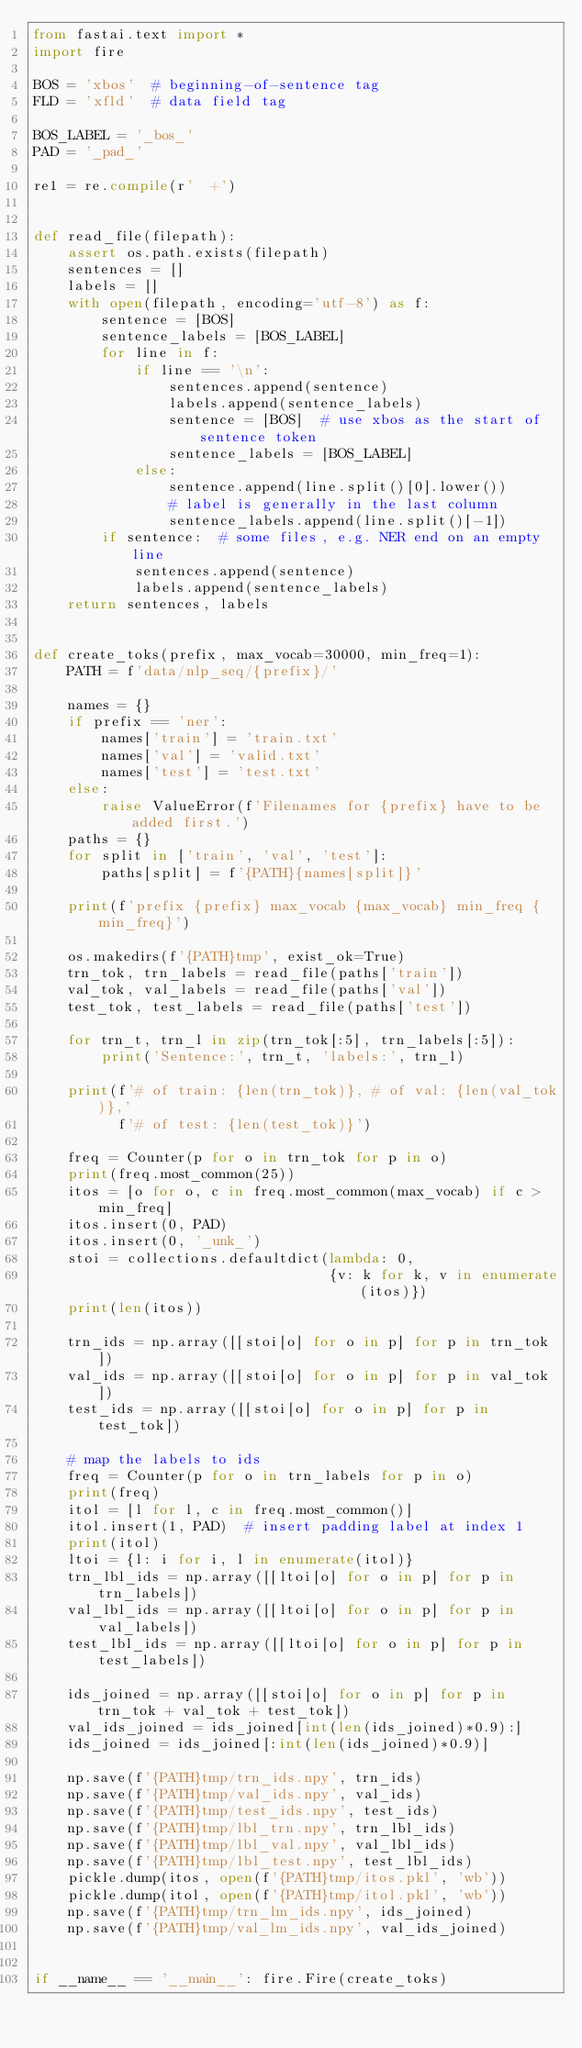<code> <loc_0><loc_0><loc_500><loc_500><_Python_>from fastai.text import *
import fire

BOS = 'xbos'  # beginning-of-sentence tag
FLD = 'xfld'  # data field tag

BOS_LABEL = '_bos_'
PAD = '_pad_'

re1 = re.compile(r'  +')


def read_file(filepath):
    assert os.path.exists(filepath)
    sentences = []
    labels = []
    with open(filepath, encoding='utf-8') as f:
        sentence = [BOS]
        sentence_labels = [BOS_LABEL]
        for line in f:
            if line == '\n':
                sentences.append(sentence)
                labels.append(sentence_labels)
                sentence = [BOS]  # use xbos as the start of sentence token
                sentence_labels = [BOS_LABEL]
            else:
                sentence.append(line.split()[0].lower())
                # label is generally in the last column
                sentence_labels.append(line.split()[-1])
        if sentence:  # some files, e.g. NER end on an empty line
            sentences.append(sentence)
            labels.append(sentence_labels)
    return sentences, labels


def create_toks(prefix, max_vocab=30000, min_freq=1):
    PATH = f'data/nlp_seq/{prefix}/'

    names = {}
    if prefix == 'ner':
        names['train'] = 'train.txt'
        names['val'] = 'valid.txt'
        names['test'] = 'test.txt'
    else:
        raise ValueError(f'Filenames for {prefix} have to be added first.')
    paths = {}
    for split in ['train', 'val', 'test']:
        paths[split] = f'{PATH}{names[split]}'

    print(f'prefix {prefix} max_vocab {max_vocab} min_freq {min_freq}')

    os.makedirs(f'{PATH}tmp', exist_ok=True)
    trn_tok, trn_labels = read_file(paths['train'])
    val_tok, val_labels = read_file(paths['val'])
    test_tok, test_labels = read_file(paths['test'])

    for trn_t, trn_l in zip(trn_tok[:5], trn_labels[:5]):
        print('Sentence:', trn_t, 'labels:', trn_l)

    print(f'# of train: {len(trn_tok)}, # of val: {len(val_tok)},'
          f'# of test: {len(test_tok)}')

    freq = Counter(p for o in trn_tok for p in o)
    print(freq.most_common(25))
    itos = [o for o, c in freq.most_common(max_vocab) if c > min_freq]
    itos.insert(0, PAD)
    itos.insert(0, '_unk_')
    stoi = collections.defaultdict(lambda: 0,
                                   {v: k for k, v in enumerate(itos)})
    print(len(itos))

    trn_ids = np.array([[stoi[o] for o in p] for p in trn_tok])
    val_ids = np.array([[stoi[o] for o in p] for p in val_tok])
    test_ids = np.array([[stoi[o] for o in p] for p in test_tok])

    # map the labels to ids
    freq = Counter(p for o in trn_labels for p in o)
    print(freq)
    itol = [l for l, c in freq.most_common()]
    itol.insert(1, PAD)  # insert padding label at index 1
    print(itol)
    ltoi = {l: i for i, l in enumerate(itol)}
    trn_lbl_ids = np.array([[ltoi[o] for o in p] for p in trn_labels])
    val_lbl_ids = np.array([[ltoi[o] for o in p] for p in val_labels])
    test_lbl_ids = np.array([[ltoi[o] for o in p] for p in test_labels])

    ids_joined = np.array([[stoi[o] for o in p] for p in trn_tok + val_tok + test_tok])
    val_ids_joined = ids_joined[int(len(ids_joined)*0.9):]
    ids_joined = ids_joined[:int(len(ids_joined)*0.9)]

    np.save(f'{PATH}tmp/trn_ids.npy', trn_ids)
    np.save(f'{PATH}tmp/val_ids.npy', val_ids)
    np.save(f'{PATH}tmp/test_ids.npy', test_ids)
    np.save(f'{PATH}tmp/lbl_trn.npy', trn_lbl_ids)
    np.save(f'{PATH}tmp/lbl_val.npy', val_lbl_ids)
    np.save(f'{PATH}tmp/lbl_test.npy', test_lbl_ids)
    pickle.dump(itos, open(f'{PATH}tmp/itos.pkl', 'wb'))
    pickle.dump(itol, open(f'{PATH}tmp/itol.pkl', 'wb'))
    np.save(f'{PATH}tmp/trn_lm_ids.npy', ids_joined)
    np.save(f'{PATH}tmp/val_lm_ids.npy', val_ids_joined)


if __name__ == '__main__': fire.Fire(create_toks)
</code> 